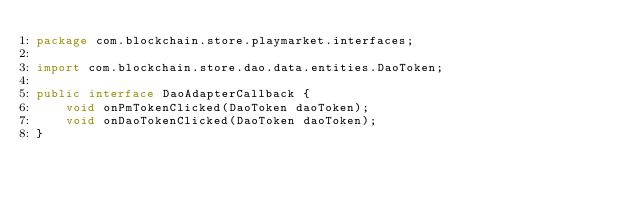<code> <loc_0><loc_0><loc_500><loc_500><_Java_>package com.blockchain.store.playmarket.interfaces;

import com.blockchain.store.dao.data.entities.DaoToken;

public interface DaoAdapterCallback {
    void onPmTokenClicked(DaoToken daoToken);
    void onDaoTokenClicked(DaoToken daoToken);
}</code> 